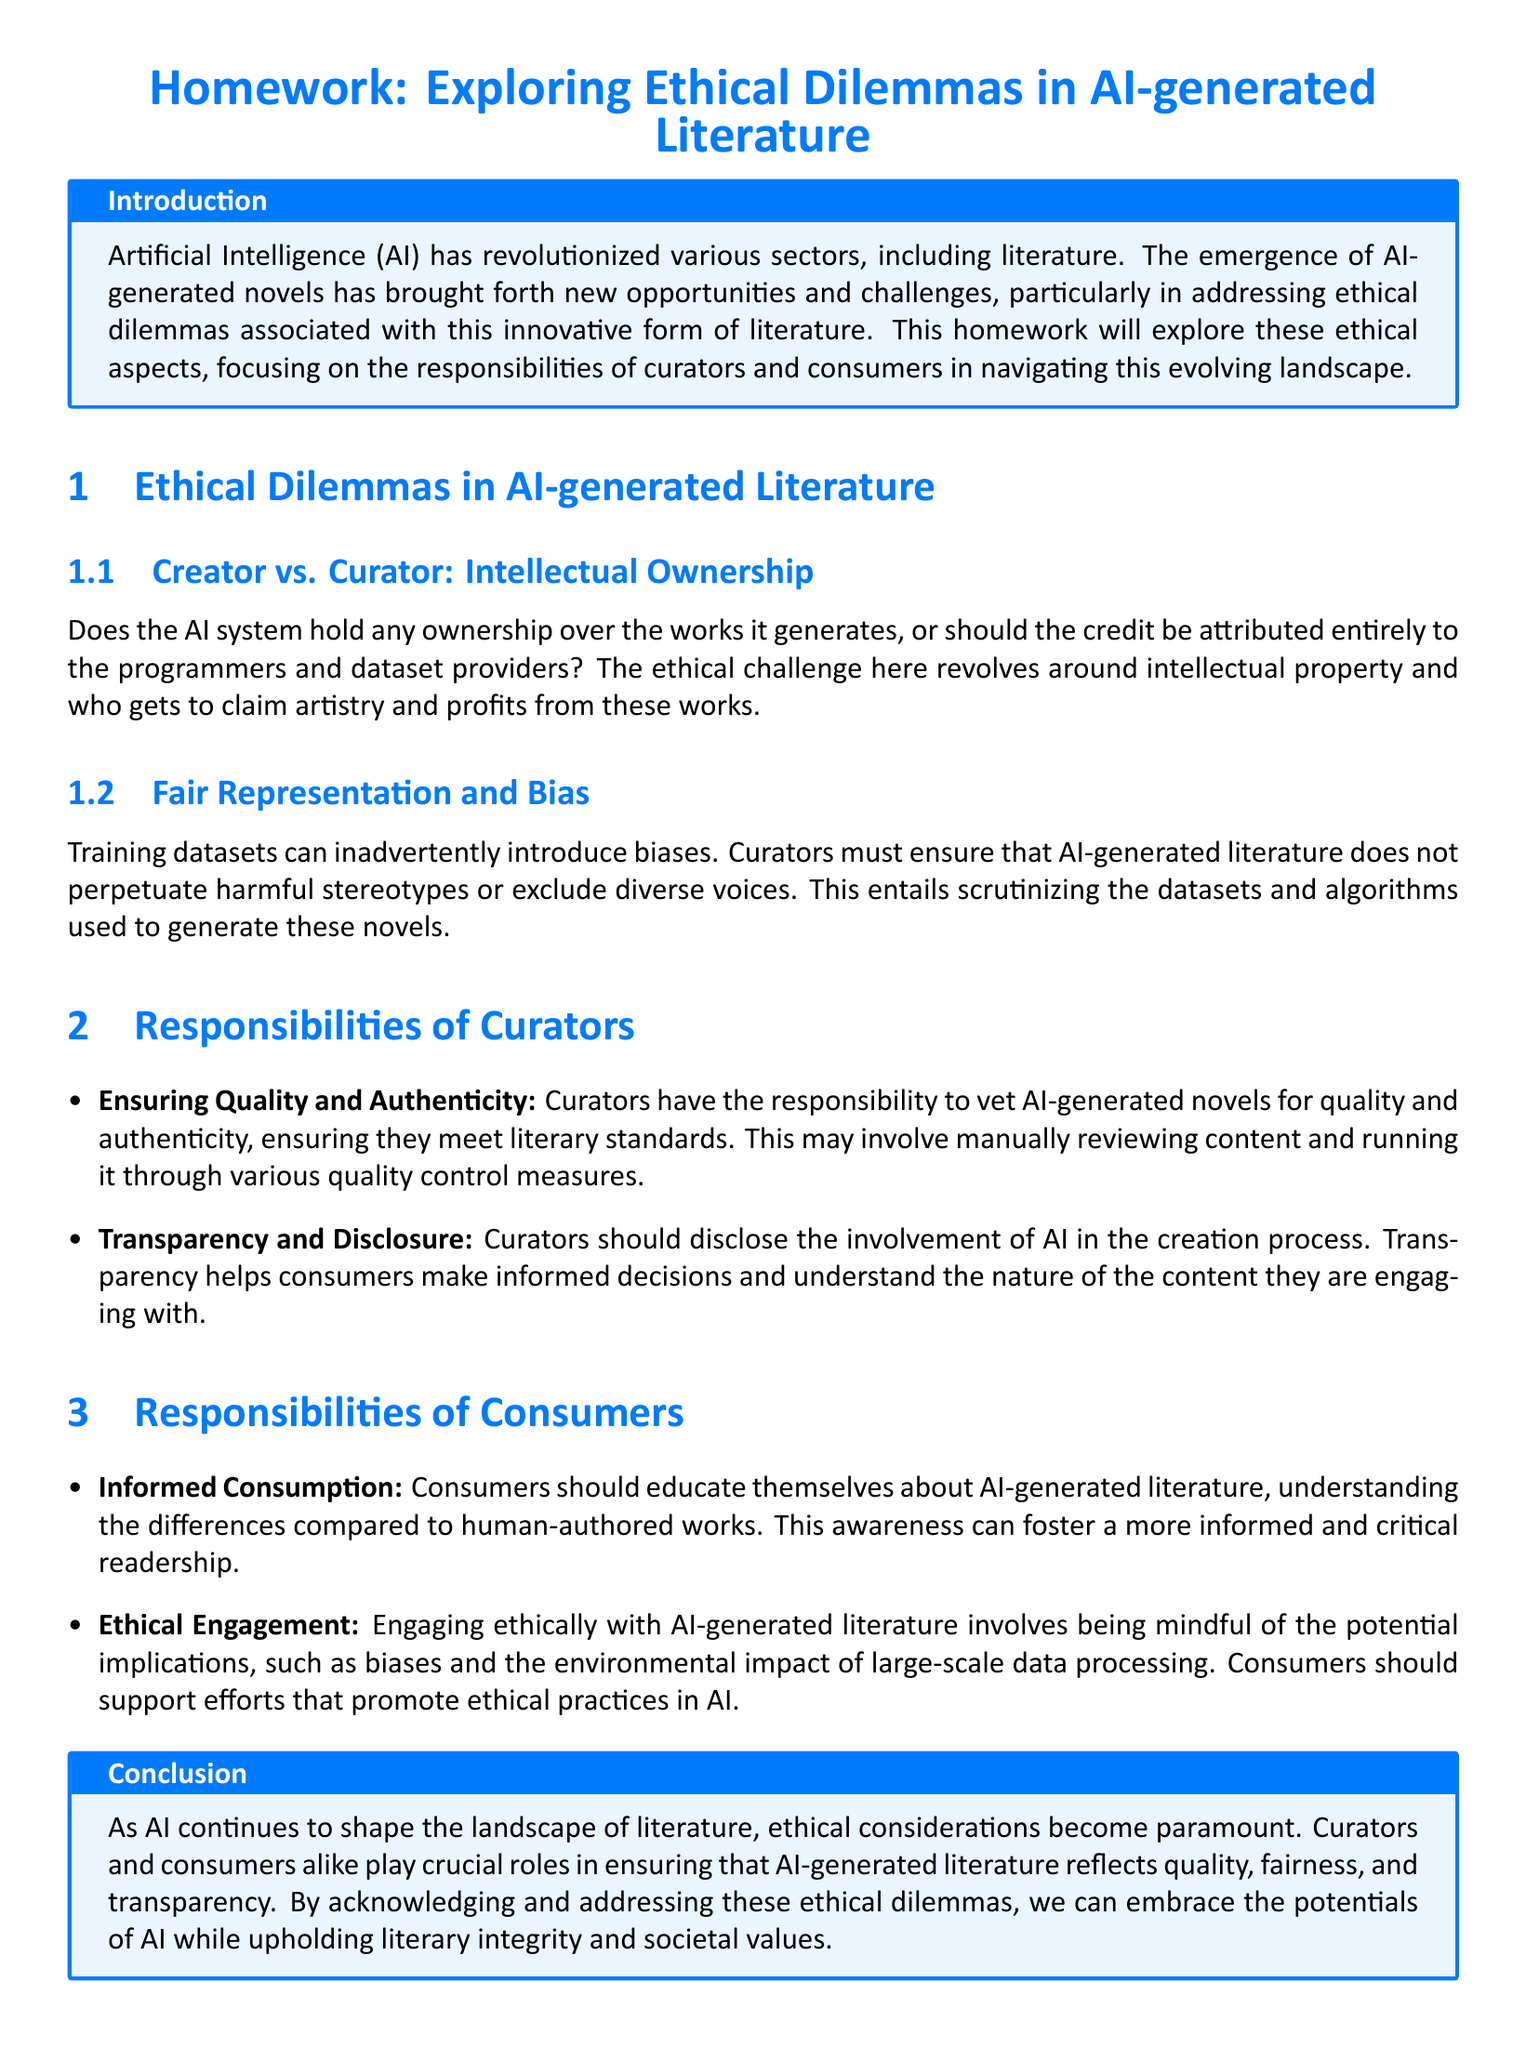What is the title of the homework? The title of the homework is stated prominently at the beginning of the document.
Answer: Homework: Exploring Ethical Dilemmas in AI-generated Literature What are the two main ethical dilemmas discussed? The document outlines two specific dilemmas related to AI-generated literature in the section "Ethical Dilemmas in AI-generated Literature."
Answer: Creator vs. Curator: Intellectual Ownership, Fair Representation and Bias What responsibility do curators have regarding quality? The document specifies the responsibilities of curators, including ensuring literary quality and authenticity.
Answer: Ensuring Quality and Authenticity What should curators disclose? The responsibilities section highlights that curators should maintain transparency about AI involvement.
Answer: Transparency and Disclosure What type of engagement should consumers promote? The document emphasizes that consumers should engage ethically with AI-generated literature, supporting responsible practices.
Answer: Ethical Engagement How many responsibilities of curators are mentioned? The document lists specific responsibilities for curators in an itemized list.
Answer: Two What is the conclusion about AI-generated literature? The conclusion summarizes the overall importance of the discussed ethical considerations in AI-generated literature.
Answer: Ethical considerations become paramount What is encouraged for consumers to do in terms of their understanding? The responsibilities section for consumers highlights the importance of being informed.
Answer: Informed Consumption 